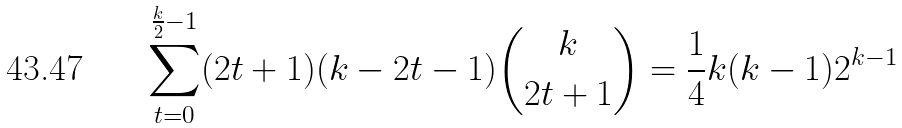<formula> <loc_0><loc_0><loc_500><loc_500>\sum _ { t = 0 } ^ { \frac { k } { 2 } - 1 } ( 2 t + 1 ) ( k - 2 t - 1 ) { { k } \choose { 2 t + 1 } } = \frac { 1 } { 4 } k ( k - 1 ) 2 ^ { k - 1 }</formula> 